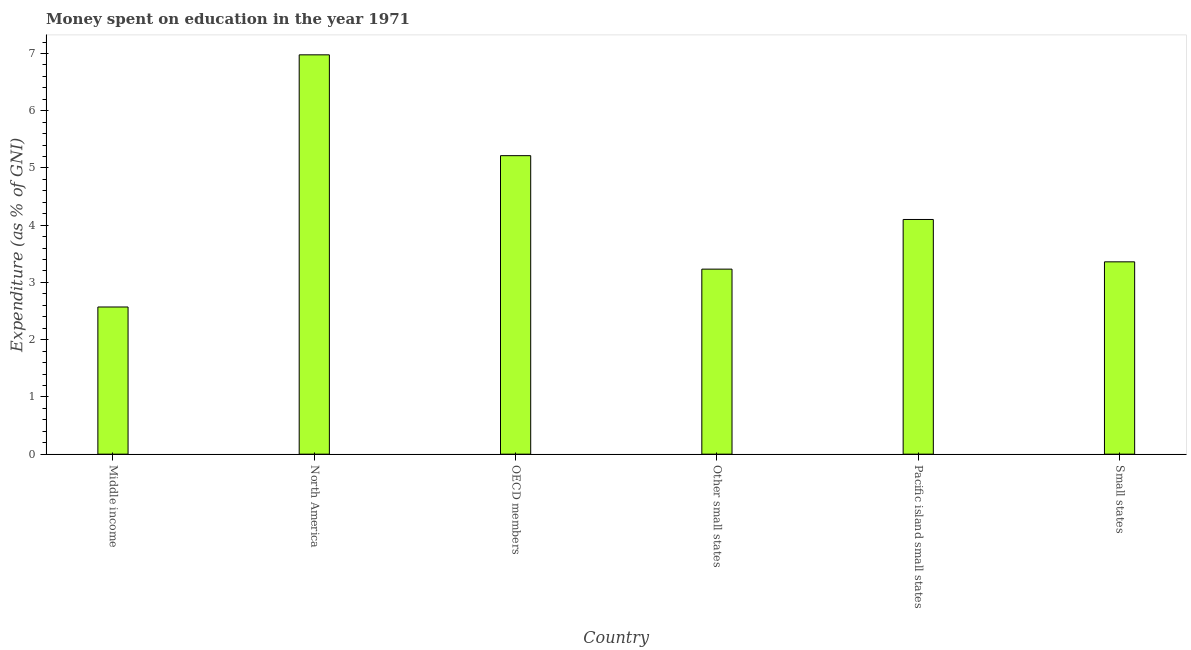What is the title of the graph?
Offer a very short reply. Money spent on education in the year 1971. What is the label or title of the Y-axis?
Keep it short and to the point. Expenditure (as % of GNI). What is the expenditure on education in Middle income?
Provide a short and direct response. 2.57. Across all countries, what is the maximum expenditure on education?
Keep it short and to the point. 6.98. Across all countries, what is the minimum expenditure on education?
Provide a short and direct response. 2.57. In which country was the expenditure on education maximum?
Keep it short and to the point. North America. In which country was the expenditure on education minimum?
Your answer should be compact. Middle income. What is the sum of the expenditure on education?
Offer a terse response. 25.45. What is the difference between the expenditure on education in OECD members and Pacific island small states?
Offer a very short reply. 1.11. What is the average expenditure on education per country?
Offer a very short reply. 4.24. What is the median expenditure on education?
Your answer should be very brief. 3.73. What is the ratio of the expenditure on education in Middle income to that in Small states?
Keep it short and to the point. 0.77. Is the expenditure on education in Middle income less than that in North America?
Give a very brief answer. Yes. What is the difference between the highest and the second highest expenditure on education?
Provide a short and direct response. 1.76. What is the difference between the highest and the lowest expenditure on education?
Provide a short and direct response. 4.4. What is the difference between two consecutive major ticks on the Y-axis?
Give a very brief answer. 1. What is the Expenditure (as % of GNI) of Middle income?
Offer a very short reply. 2.57. What is the Expenditure (as % of GNI) in North America?
Provide a short and direct response. 6.98. What is the Expenditure (as % of GNI) of OECD members?
Offer a very short reply. 5.21. What is the Expenditure (as % of GNI) of Other small states?
Offer a terse response. 3.23. What is the Expenditure (as % of GNI) in Small states?
Give a very brief answer. 3.36. What is the difference between the Expenditure (as % of GNI) in Middle income and North America?
Keep it short and to the point. -4.41. What is the difference between the Expenditure (as % of GNI) in Middle income and OECD members?
Ensure brevity in your answer.  -2.64. What is the difference between the Expenditure (as % of GNI) in Middle income and Other small states?
Offer a terse response. -0.66. What is the difference between the Expenditure (as % of GNI) in Middle income and Pacific island small states?
Give a very brief answer. -1.53. What is the difference between the Expenditure (as % of GNI) in Middle income and Small states?
Make the answer very short. -0.79. What is the difference between the Expenditure (as % of GNI) in North America and OECD members?
Make the answer very short. 1.76. What is the difference between the Expenditure (as % of GNI) in North America and Other small states?
Offer a terse response. 3.74. What is the difference between the Expenditure (as % of GNI) in North America and Pacific island small states?
Your response must be concise. 2.88. What is the difference between the Expenditure (as % of GNI) in North America and Small states?
Provide a succinct answer. 3.62. What is the difference between the Expenditure (as % of GNI) in OECD members and Other small states?
Your answer should be very brief. 1.98. What is the difference between the Expenditure (as % of GNI) in OECD members and Pacific island small states?
Your answer should be very brief. 1.11. What is the difference between the Expenditure (as % of GNI) in OECD members and Small states?
Provide a succinct answer. 1.85. What is the difference between the Expenditure (as % of GNI) in Other small states and Pacific island small states?
Provide a short and direct response. -0.87. What is the difference between the Expenditure (as % of GNI) in Other small states and Small states?
Make the answer very short. -0.13. What is the difference between the Expenditure (as % of GNI) in Pacific island small states and Small states?
Your answer should be compact. 0.74. What is the ratio of the Expenditure (as % of GNI) in Middle income to that in North America?
Keep it short and to the point. 0.37. What is the ratio of the Expenditure (as % of GNI) in Middle income to that in OECD members?
Give a very brief answer. 0.49. What is the ratio of the Expenditure (as % of GNI) in Middle income to that in Other small states?
Ensure brevity in your answer.  0.8. What is the ratio of the Expenditure (as % of GNI) in Middle income to that in Pacific island small states?
Your answer should be compact. 0.63. What is the ratio of the Expenditure (as % of GNI) in Middle income to that in Small states?
Make the answer very short. 0.77. What is the ratio of the Expenditure (as % of GNI) in North America to that in OECD members?
Your response must be concise. 1.34. What is the ratio of the Expenditure (as % of GNI) in North America to that in Other small states?
Make the answer very short. 2.16. What is the ratio of the Expenditure (as % of GNI) in North America to that in Pacific island small states?
Keep it short and to the point. 1.7. What is the ratio of the Expenditure (as % of GNI) in North America to that in Small states?
Your answer should be compact. 2.08. What is the ratio of the Expenditure (as % of GNI) in OECD members to that in Other small states?
Your answer should be compact. 1.61. What is the ratio of the Expenditure (as % of GNI) in OECD members to that in Pacific island small states?
Offer a terse response. 1.27. What is the ratio of the Expenditure (as % of GNI) in OECD members to that in Small states?
Your response must be concise. 1.55. What is the ratio of the Expenditure (as % of GNI) in Other small states to that in Pacific island small states?
Provide a succinct answer. 0.79. What is the ratio of the Expenditure (as % of GNI) in Pacific island small states to that in Small states?
Provide a short and direct response. 1.22. 